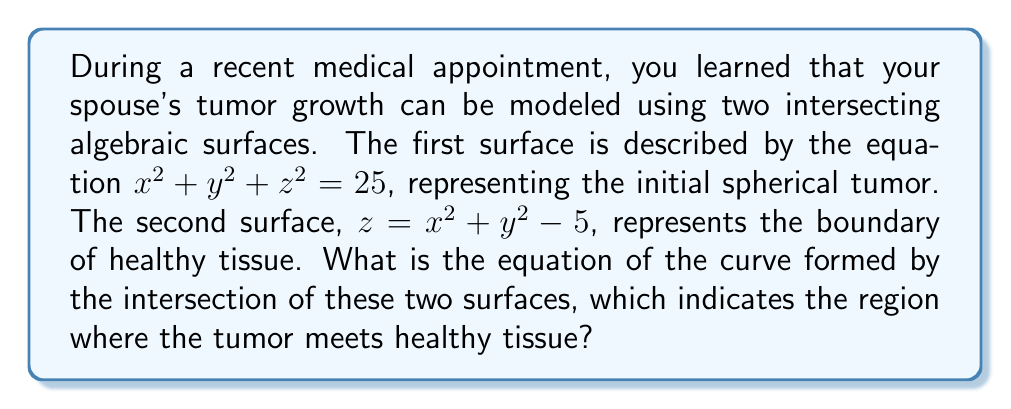Can you answer this question? Let's approach this step-by-step:

1) We have two equations:
   
   Surface 1 (tumor): $x^2 + y^2 + z^2 = 25$
   Surface 2 (healthy tissue boundary): $z = x^2 + y^2 - 5$

2) To find the intersection, we need to solve these equations simultaneously. We can do this by substituting the expression for $z$ from the second equation into the first:

   $x^2 + y^2 + (x^2 + y^2 - 5)^2 = 25$

3) Expand the squared term:
   
   $x^2 + y^2 + (x^2 + y^2)^2 - 10(x^2 + y^2) + 25 = 25$

4) Simplify:
   
   $x^2 + y^2 + (x^2 + y^2)^2 - 10(x^2 + y^2) = 0$

5) Let $u = x^2 + y^2$ for simplicity:
   
   $u + u^2 - 10u = 0$

6) Factor out $u$:
   
   $u(1 + u - 10) = 0$

7) Solve this equation:
   
   Either $u = 0$ or $1 + u - 10 = 0$
   
   If $u = 0$, then $x = y = 0$, which is just a point.
   
   From $1 + u - 10 = 0$, we get $u = 9$

8) Therefore, the intersection curve is described by:

   $x^2 + y^2 = 9$ and $z = 4$

This is a circle with radius 3 in the plane $z = 4$.
Answer: $x^2 + y^2 = 9$, $z = 4$ 